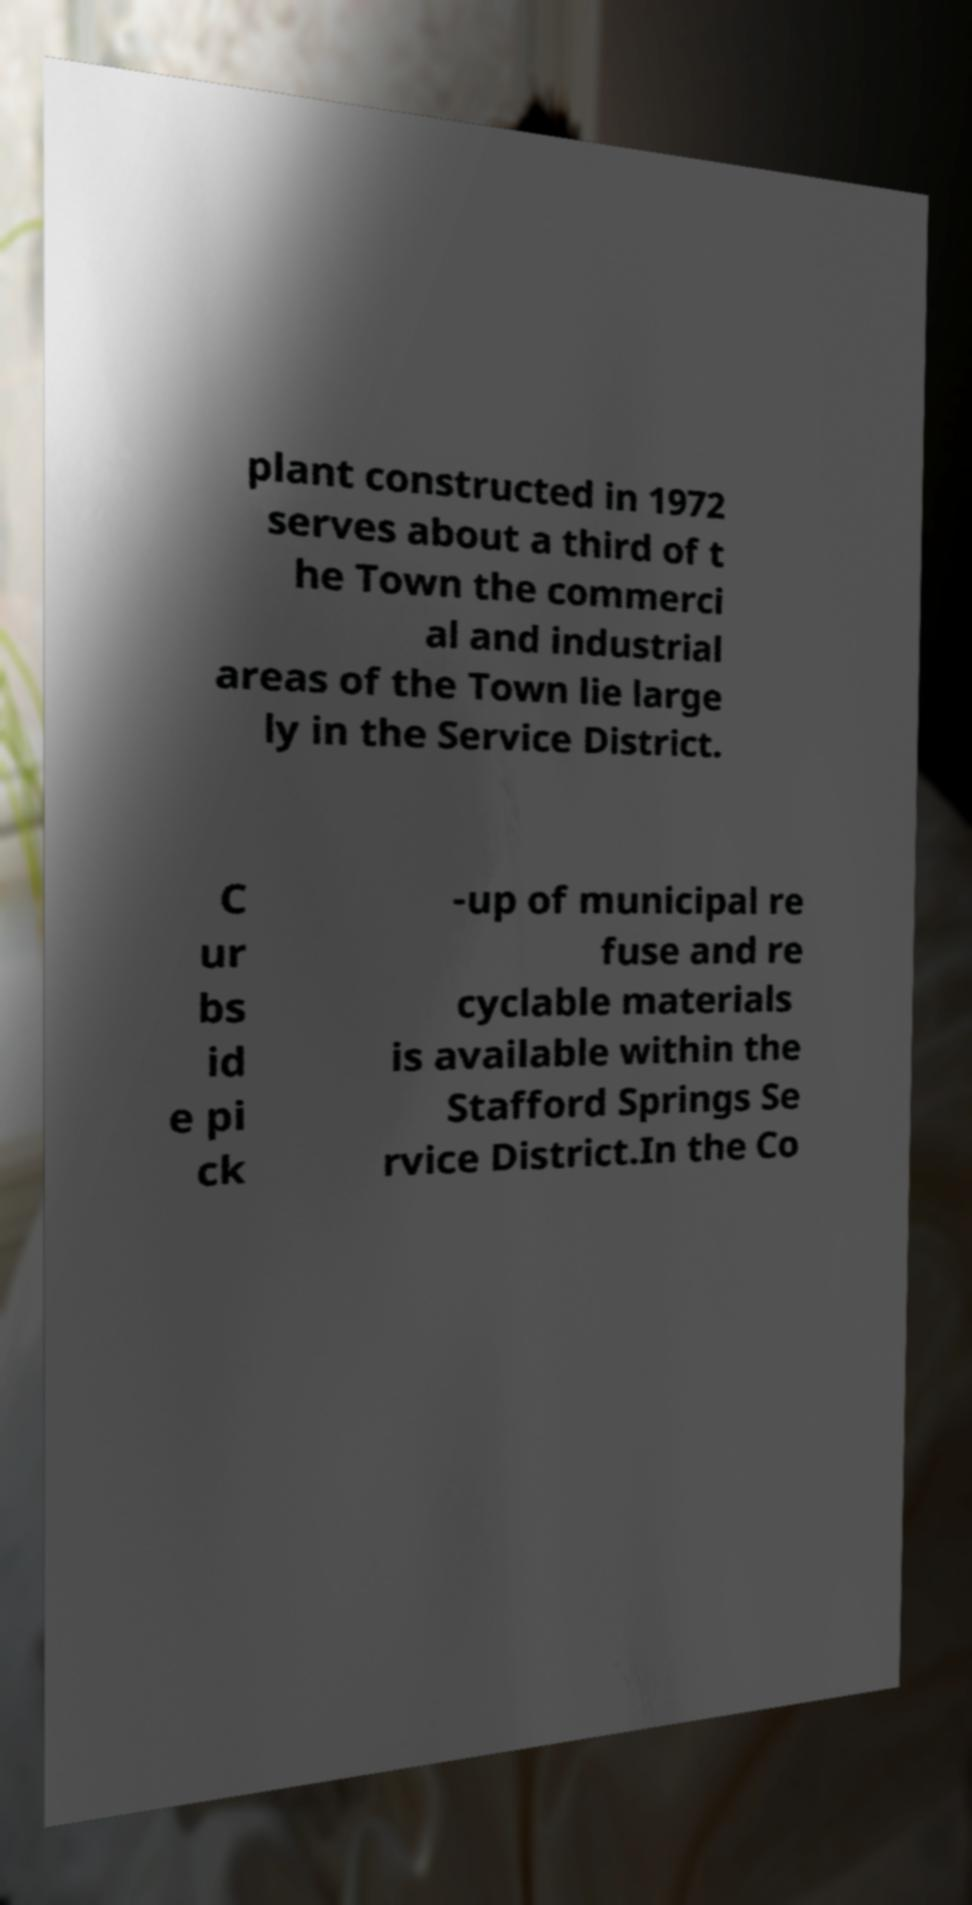Can you accurately transcribe the text from the provided image for me? plant constructed in 1972 serves about a third of t he Town the commerci al and industrial areas of the Town lie large ly in the Service District. C ur bs id e pi ck -up of municipal re fuse and re cyclable materials is available within the Stafford Springs Se rvice District.In the Co 